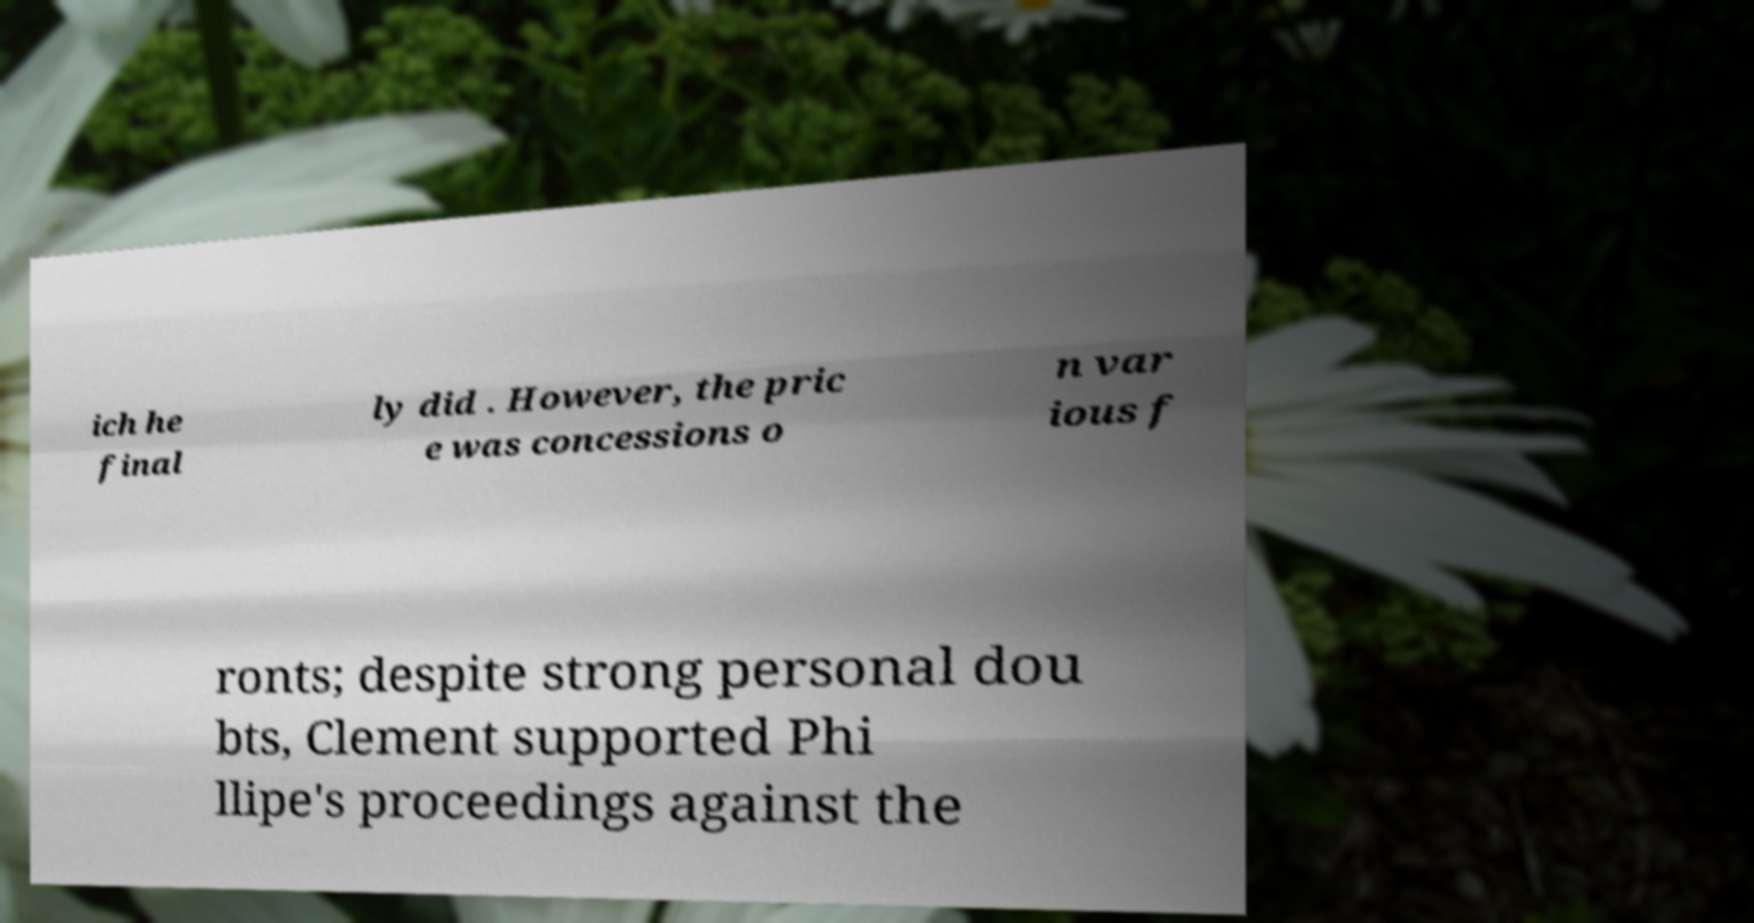I need the written content from this picture converted into text. Can you do that? ich he final ly did . However, the pric e was concessions o n var ious f ronts; despite strong personal dou bts, Clement supported Phi llipe's proceedings against the 